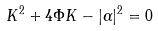Convert formula to latex. <formula><loc_0><loc_0><loc_500><loc_500>K ^ { 2 } + 4 \Phi K - | \alpha | ^ { 2 } = 0</formula> 